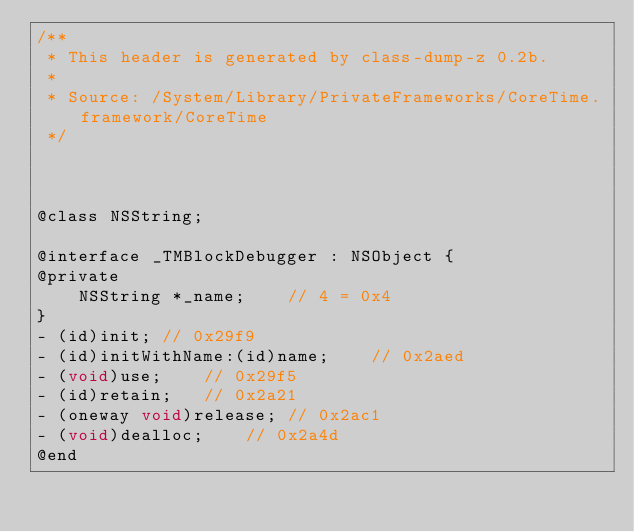Convert code to text. <code><loc_0><loc_0><loc_500><loc_500><_C_>/**
 * This header is generated by class-dump-z 0.2b.
 *
 * Source: /System/Library/PrivateFrameworks/CoreTime.framework/CoreTime
 */



@class NSString;

@interface _TMBlockDebugger : NSObject {
@private
	NSString *_name;	// 4 = 0x4
}
- (id)init;	// 0x29f9
- (id)initWithName:(id)name;	// 0x2aed
- (void)use;	// 0x29f5
- (id)retain;	// 0x2a21
- (oneway void)release;	// 0x2ac1
- (void)dealloc;	// 0x2a4d
@end
</code> 